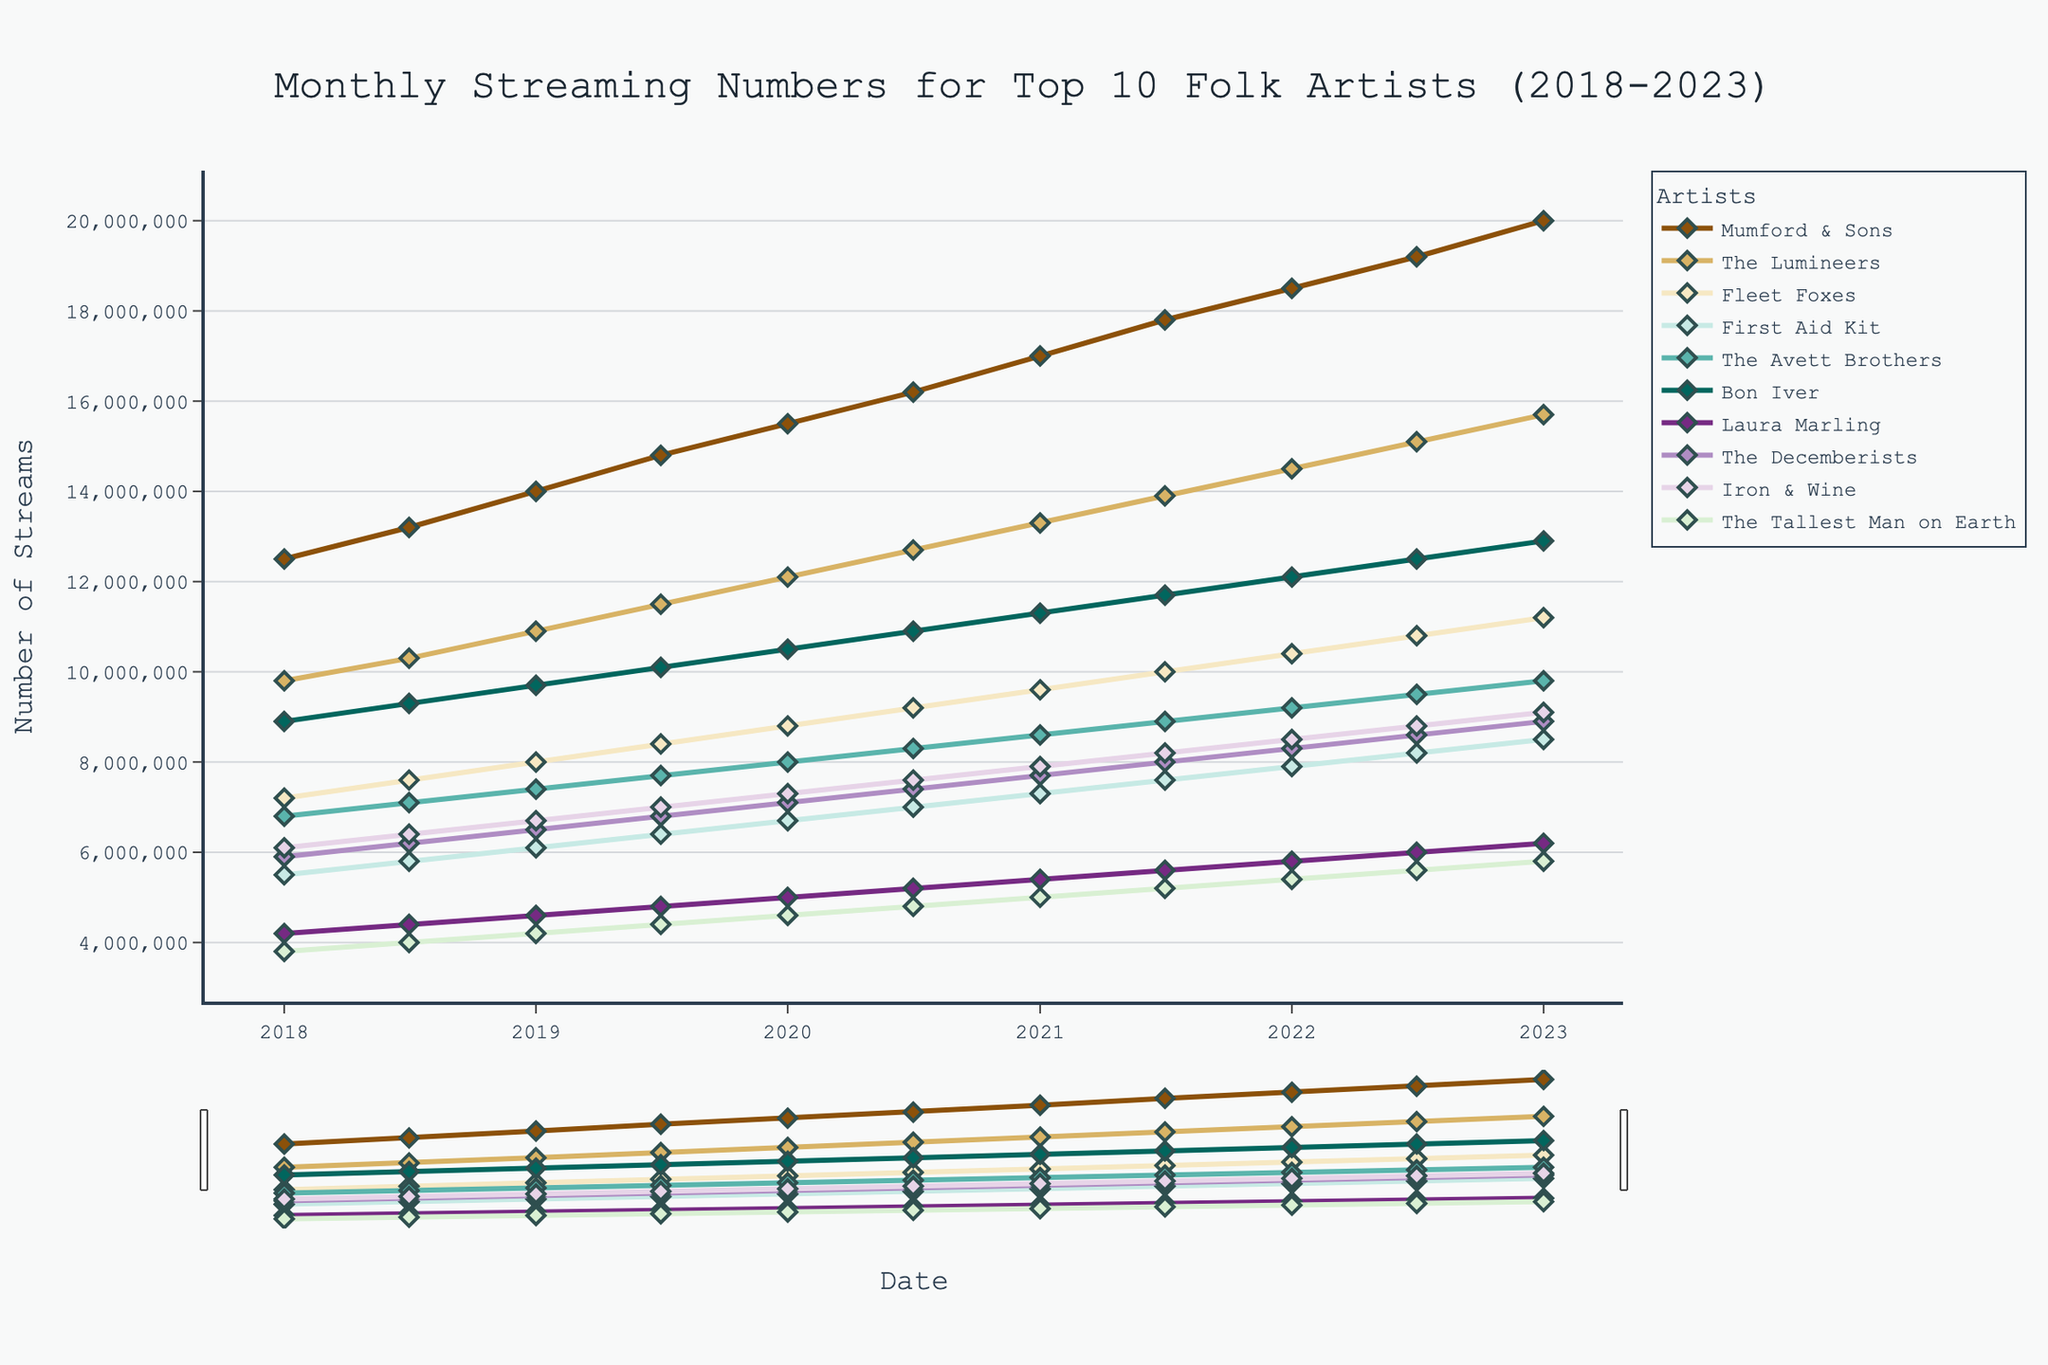Which artist had the highest streaming numbers in January 2018? By looking at the starting data points for January 2018 on the line chart, we can identify the artist with the highest streaming numbers. Mumford & Sons appear to have the highest streaming numbers at around 12,500,000 streams.
Answer: Mumford & Sons How much did The Lumineers' streaming numbers increase from January 2018 to January 2023? First, locate The Lumineers' data points for January 2018 and January 2023, which are approximately 9,800,000 and 15,700,000 respectively. The increase is calculated by subtracting the initial value from the final value (15,700,000 - 9,800,000).
Answer: 5,900,000 Which artist showed the least growth in streaming numbers over the 5-year period? To determine the artist with the least growth, compare the increase in streaming numbers from January 2018 to January 2023 for each artist. The Tallest Man on Earth appears to have the smallest increase, growing from approximately 3,800,000 to 5,800,000 streams.
Answer: The Tallest Man on Earth Which two artists had their streaming numbers closest to each other in July 2021? In July 2021, observe the data points and find the two artists whose streaming numbers are closest together. First Aid Kit and The Decemberists both had streaming numbers close to 7,600,000.
Answer: First Aid Kit and The Decemberists Who had higher streaming numbers in July 2020: Fleet Foxes or The Avett Brothers? By checking the data points for Fleet Foxes and The Avett Brothers in July 2020, we see that Fleet Foxes had around 9,200,000 and The Avett Brothers had around 8,300,000 streams. Fleet Foxes had higher streaming numbers.
Answer: Fleet Foxes What is the average number of streams for Mumford & Sons across all the given months? Add up all the data points for Mumford & Sons from January 2018 to January 2023 and divide by the number of data points (11). (12,500,000 + 13,200,000 + 14,000,000 + 14,800,000 + 15,500,000 + 16,200,000 + 17,000,000 + 17,800,000 + 18,500,000 + 19,200,000 + 20,000,000) / 11 = 16,500,000
Answer: 16,500,000 Which artist had the fastest growth in streaming numbers between January 2021 to January 2022? To find the artist with the fastest growth, compare the increase in streaming numbers for January 2021 to January 2022 for each artist. Mumford & Sons grew from approximately 17,000,000 to 18,500,000, which is the highest increase of 1,500,000 streams.
Answer: Mumford & Sons 